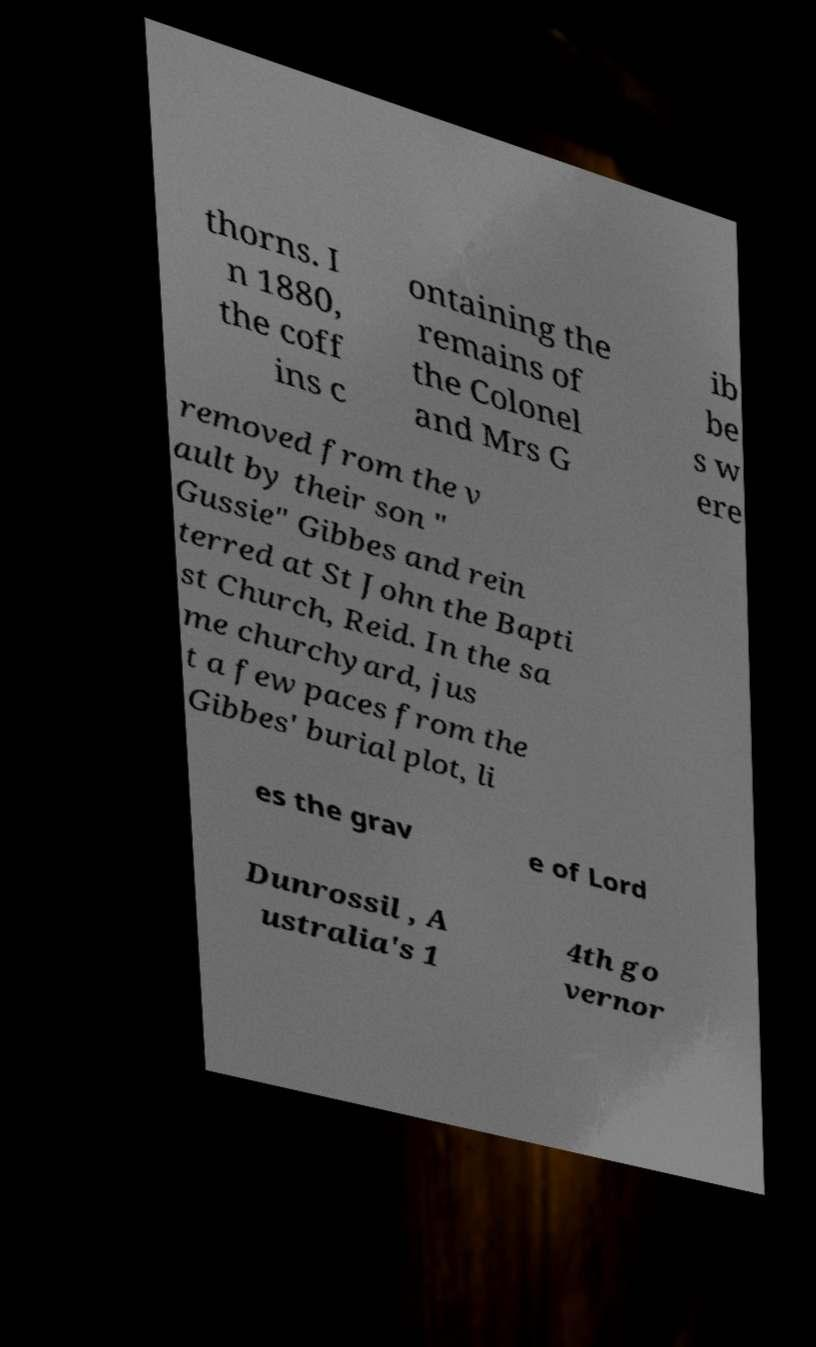Please read and relay the text visible in this image. What does it say? thorns. I n 1880, the coff ins c ontaining the remains of the Colonel and Mrs G ib be s w ere removed from the v ault by their son " Gussie" Gibbes and rein terred at St John the Bapti st Church, Reid. In the sa me churchyard, jus t a few paces from the Gibbes' burial plot, li es the grav e of Lord Dunrossil , A ustralia's 1 4th go vernor 